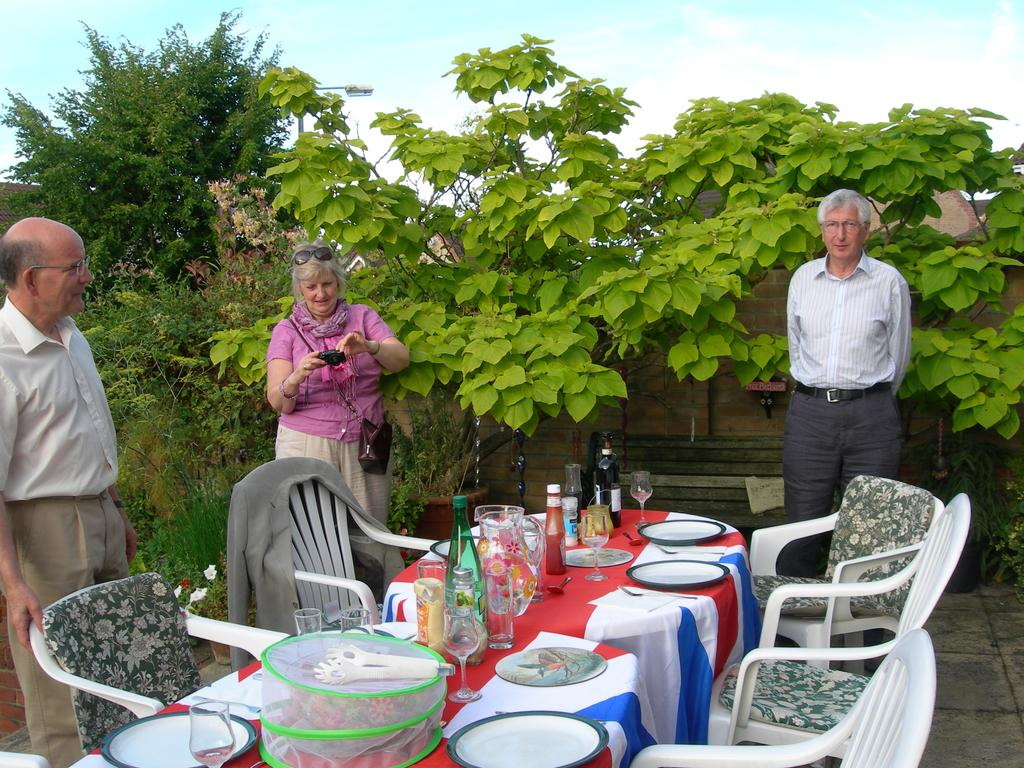How many people are in the image? There are three persons in the image. What are the persons doing in the image? The persons are standing in front of chairs and tables. What can be seen on the tables? There are eatables on the tables. What is visible in the background of the image? There are trees in the background of the image. Can you tell me how many mouths are visible in the image? There is no specific mention of mouths in the provided facts, so it is not possible to determine the number of mouths visible in the image. 